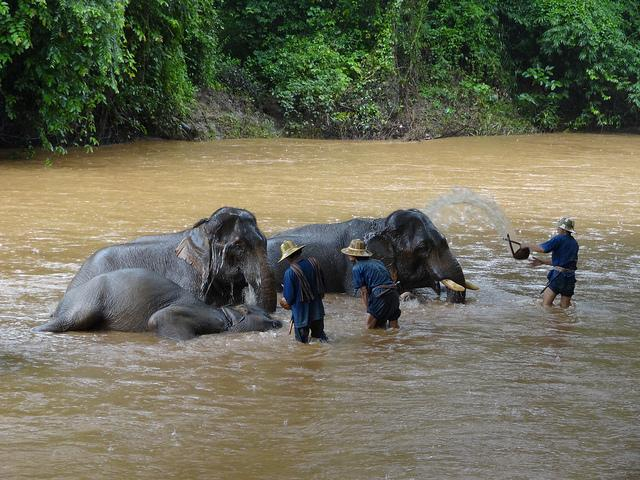What are the people doing to the elephants?

Choices:
A) hunting
B) grooming
C) cooling
D) feeding cooling 